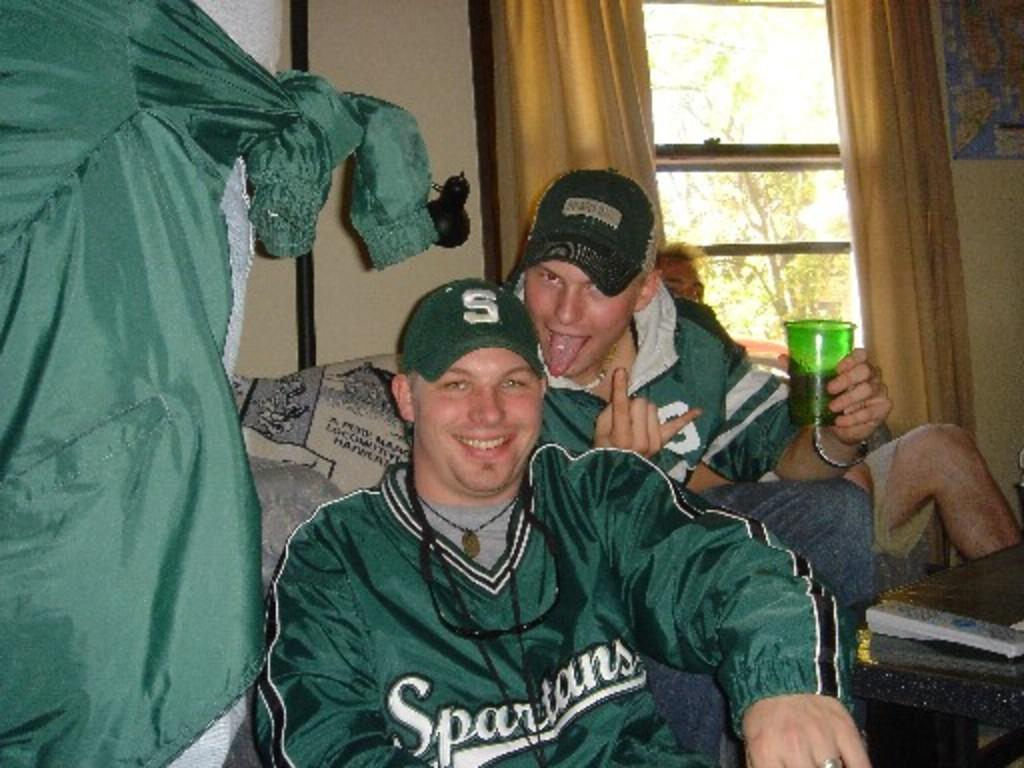<image>
Present a compact description of the photo's key features. Men wearing Spartans gear while sitting at home. 